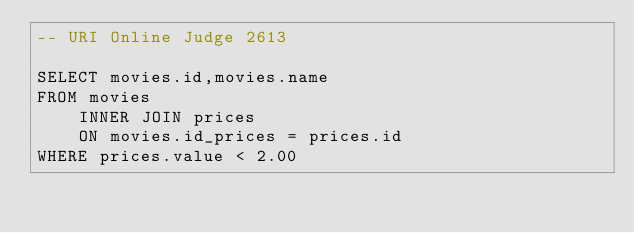Convert code to text. <code><loc_0><loc_0><loc_500><loc_500><_SQL_>-- URI Online Judge 2613

SELECT movies.id,movies.name
FROM movies
    INNER JOIN prices 
    ON movies.id_prices = prices.id
WHERE prices.value < 2.00</code> 